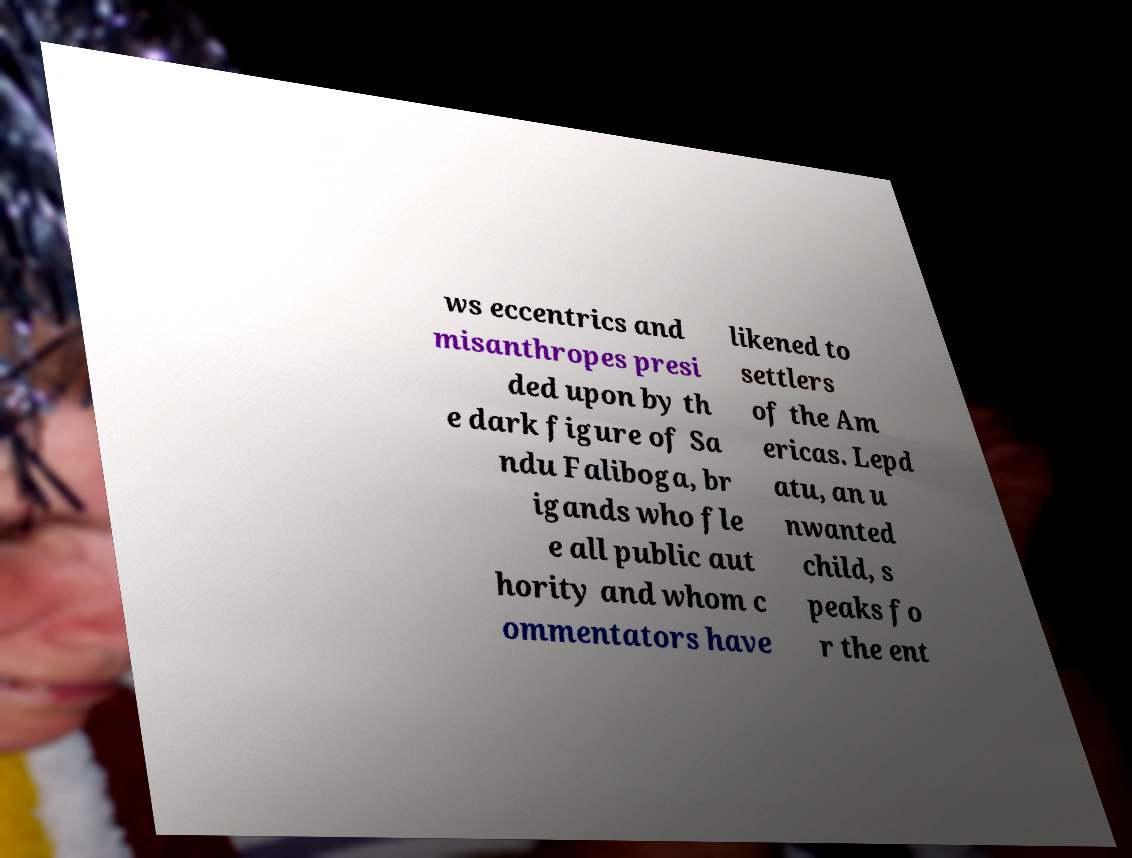Please read and relay the text visible in this image. What does it say? ws eccentrics and misanthropes presi ded upon by th e dark figure of Sa ndu Faliboga, br igands who fle e all public aut hority and whom c ommentators have likened to settlers of the Am ericas. Lepd atu, an u nwanted child, s peaks fo r the ent 